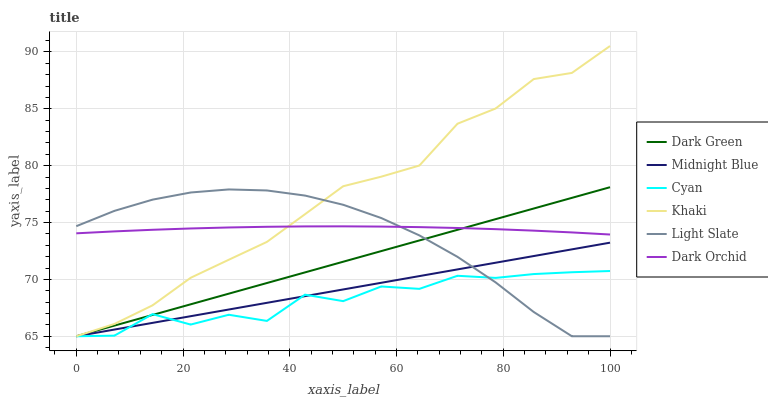Does Cyan have the minimum area under the curve?
Answer yes or no. Yes. Does Khaki have the maximum area under the curve?
Answer yes or no. Yes. Does Midnight Blue have the minimum area under the curve?
Answer yes or no. No. Does Midnight Blue have the maximum area under the curve?
Answer yes or no. No. Is Dark Green the smoothest?
Answer yes or no. Yes. Is Cyan the roughest?
Answer yes or no. Yes. Is Midnight Blue the smoothest?
Answer yes or no. No. Is Midnight Blue the roughest?
Answer yes or no. No. Does Khaki have the lowest value?
Answer yes or no. Yes. Does Dark Orchid have the lowest value?
Answer yes or no. No. Does Khaki have the highest value?
Answer yes or no. Yes. Does Midnight Blue have the highest value?
Answer yes or no. No. Is Midnight Blue less than Dark Orchid?
Answer yes or no. Yes. Is Dark Orchid greater than Midnight Blue?
Answer yes or no. Yes. Does Dark Green intersect Light Slate?
Answer yes or no. Yes. Is Dark Green less than Light Slate?
Answer yes or no. No. Is Dark Green greater than Light Slate?
Answer yes or no. No. Does Midnight Blue intersect Dark Orchid?
Answer yes or no. No. 